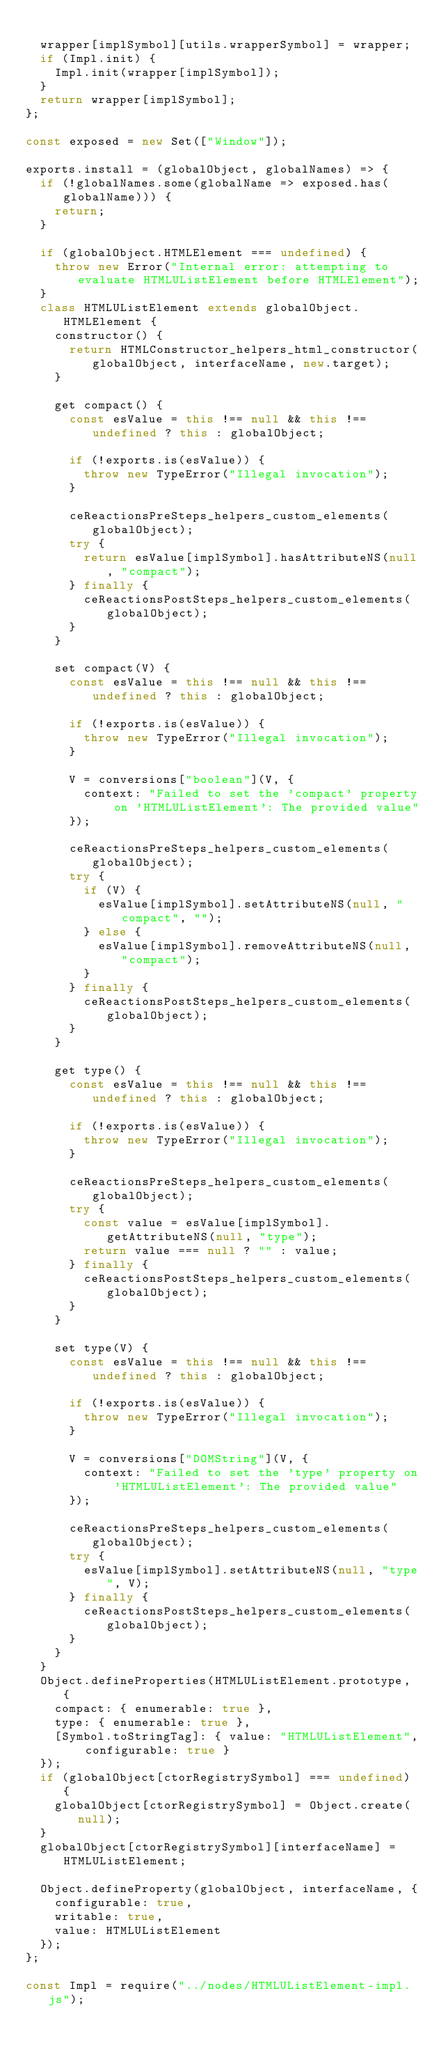Convert code to text. <code><loc_0><loc_0><loc_500><loc_500><_JavaScript_>
  wrapper[implSymbol][utils.wrapperSymbol] = wrapper;
  if (Impl.init) {
    Impl.init(wrapper[implSymbol]);
  }
  return wrapper[implSymbol];
};

const exposed = new Set(["Window"]);

exports.install = (globalObject, globalNames) => {
  if (!globalNames.some(globalName => exposed.has(globalName))) {
    return;
  }

  if (globalObject.HTMLElement === undefined) {
    throw new Error("Internal error: attempting to evaluate HTMLUListElement before HTMLElement");
  }
  class HTMLUListElement extends globalObject.HTMLElement {
    constructor() {
      return HTMLConstructor_helpers_html_constructor(globalObject, interfaceName, new.target);
    }

    get compact() {
      const esValue = this !== null && this !== undefined ? this : globalObject;

      if (!exports.is(esValue)) {
        throw new TypeError("Illegal invocation");
      }

      ceReactionsPreSteps_helpers_custom_elements(globalObject);
      try {
        return esValue[implSymbol].hasAttributeNS(null, "compact");
      } finally {
        ceReactionsPostSteps_helpers_custom_elements(globalObject);
      }
    }

    set compact(V) {
      const esValue = this !== null && this !== undefined ? this : globalObject;

      if (!exports.is(esValue)) {
        throw new TypeError("Illegal invocation");
      }

      V = conversions["boolean"](V, {
        context: "Failed to set the 'compact' property on 'HTMLUListElement': The provided value"
      });

      ceReactionsPreSteps_helpers_custom_elements(globalObject);
      try {
        if (V) {
          esValue[implSymbol].setAttributeNS(null, "compact", "");
        } else {
          esValue[implSymbol].removeAttributeNS(null, "compact");
        }
      } finally {
        ceReactionsPostSteps_helpers_custom_elements(globalObject);
      }
    }

    get type() {
      const esValue = this !== null && this !== undefined ? this : globalObject;

      if (!exports.is(esValue)) {
        throw new TypeError("Illegal invocation");
      }

      ceReactionsPreSteps_helpers_custom_elements(globalObject);
      try {
        const value = esValue[implSymbol].getAttributeNS(null, "type");
        return value === null ? "" : value;
      } finally {
        ceReactionsPostSteps_helpers_custom_elements(globalObject);
      }
    }

    set type(V) {
      const esValue = this !== null && this !== undefined ? this : globalObject;

      if (!exports.is(esValue)) {
        throw new TypeError("Illegal invocation");
      }

      V = conversions["DOMString"](V, {
        context: "Failed to set the 'type' property on 'HTMLUListElement': The provided value"
      });

      ceReactionsPreSteps_helpers_custom_elements(globalObject);
      try {
        esValue[implSymbol].setAttributeNS(null, "type", V);
      } finally {
        ceReactionsPostSteps_helpers_custom_elements(globalObject);
      }
    }
  }
  Object.defineProperties(HTMLUListElement.prototype, {
    compact: { enumerable: true },
    type: { enumerable: true },
    [Symbol.toStringTag]: { value: "HTMLUListElement", configurable: true }
  });
  if (globalObject[ctorRegistrySymbol] === undefined) {
    globalObject[ctorRegistrySymbol] = Object.create(null);
  }
  globalObject[ctorRegistrySymbol][interfaceName] = HTMLUListElement;

  Object.defineProperty(globalObject, interfaceName, {
    configurable: true,
    writable: true,
    value: HTMLUListElement
  });
};

const Impl = require("../nodes/HTMLUListElement-impl.js");
</code> 